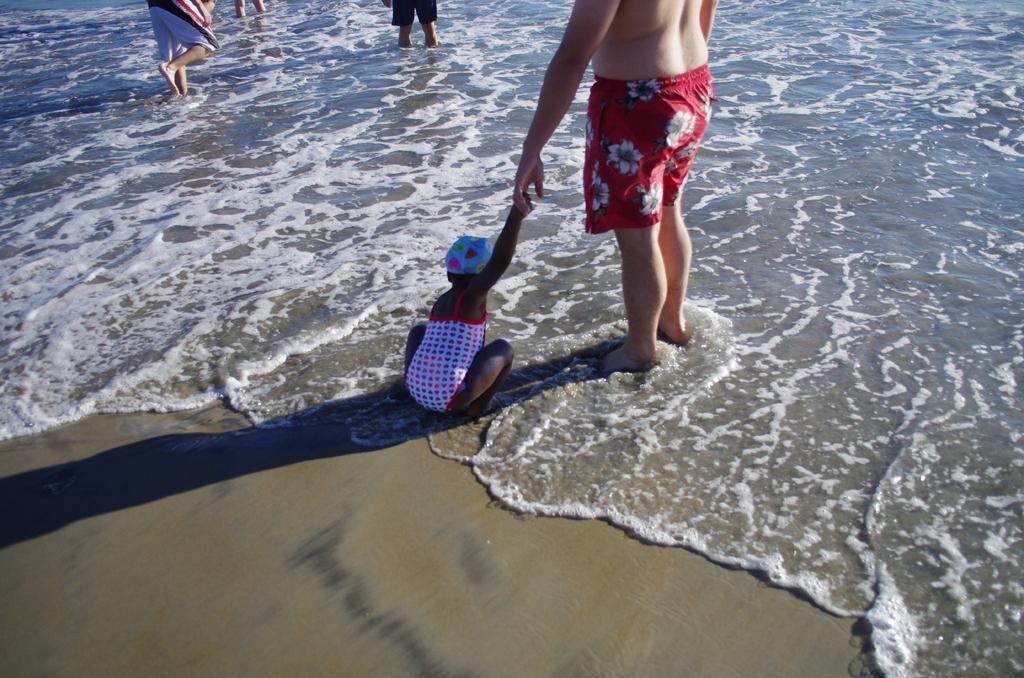What are the people in the image doing? The people in the image are standing in the water. What type of surface is under the people's feet? The ground is sand. Can you describe the position of a child in the image? A child is sitting. What type of collar is the child wearing in the image? There is no collar mentioned or visible in the image; the child is simply sitting. What scientific theory is being demonstrated in the image? There is no scientific theory being demonstrated in the image; it shows people standing in water and a child sitting on the sand. 